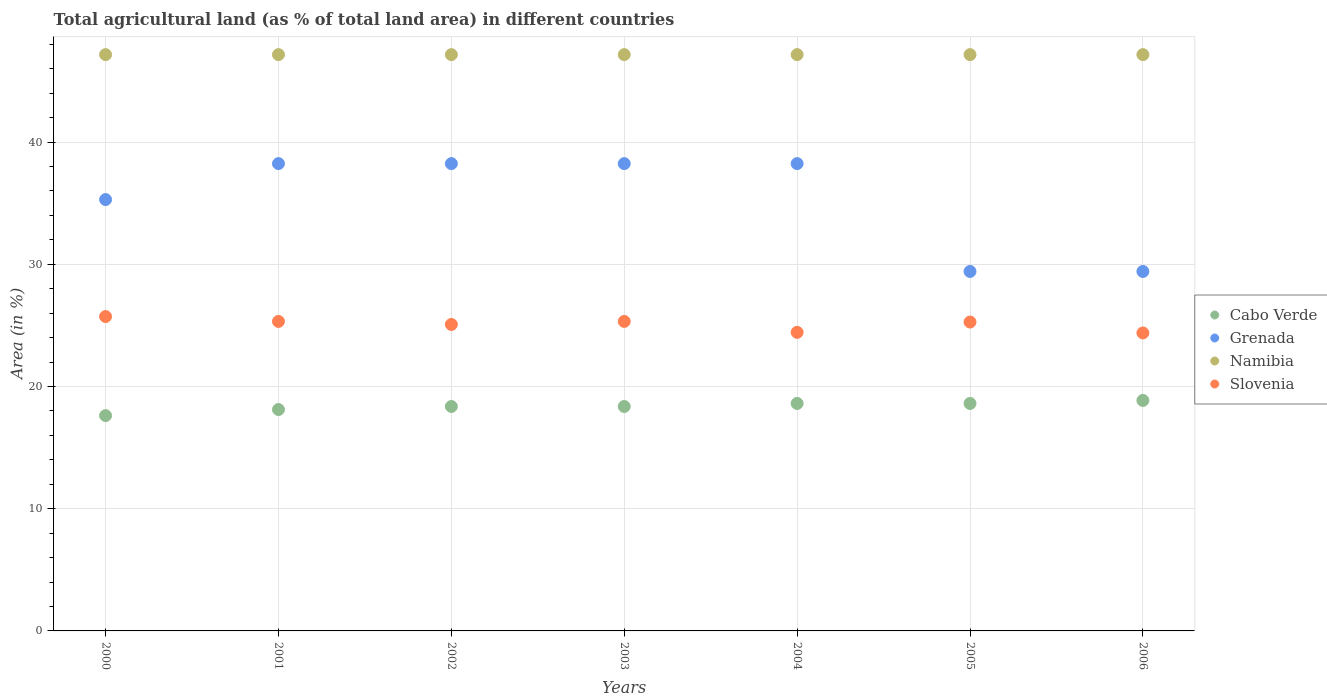How many different coloured dotlines are there?
Offer a terse response. 4. Is the number of dotlines equal to the number of legend labels?
Ensure brevity in your answer.  Yes. What is the percentage of agricultural land in Namibia in 2004?
Your answer should be very brief. 47.15. Across all years, what is the maximum percentage of agricultural land in Cabo Verde?
Give a very brief answer. 18.86. Across all years, what is the minimum percentage of agricultural land in Namibia?
Ensure brevity in your answer.  47.15. In which year was the percentage of agricultural land in Grenada minimum?
Make the answer very short. 2005. What is the total percentage of agricultural land in Cabo Verde in the graph?
Provide a succinct answer. 128.54. What is the difference between the percentage of agricultural land in Slovenia in 2000 and that in 2002?
Keep it short and to the point. 0.65. What is the difference between the percentage of agricultural land in Slovenia in 2006 and the percentage of agricultural land in Grenada in 2000?
Your response must be concise. -10.91. What is the average percentage of agricultural land in Cabo Verde per year?
Keep it short and to the point. 18.36. In the year 2003, what is the difference between the percentage of agricultural land in Namibia and percentage of agricultural land in Grenada?
Your answer should be very brief. 8.92. In how many years, is the percentage of agricultural land in Cabo Verde greater than 12 %?
Offer a very short reply. 7. What is the ratio of the percentage of agricultural land in Grenada in 2004 to that in 2006?
Offer a very short reply. 1.3. Is the percentage of agricultural land in Cabo Verde in 2000 less than that in 2001?
Keep it short and to the point. Yes. Is the difference between the percentage of agricultural land in Namibia in 2002 and 2004 greater than the difference between the percentage of agricultural land in Grenada in 2002 and 2004?
Make the answer very short. No. What is the difference between the highest and the second highest percentage of agricultural land in Grenada?
Make the answer very short. 0. What is the difference between the highest and the lowest percentage of agricultural land in Grenada?
Keep it short and to the point. 8.82. In how many years, is the percentage of agricultural land in Cabo Verde greater than the average percentage of agricultural land in Cabo Verde taken over all years?
Provide a succinct answer. 3. Is the sum of the percentage of agricultural land in Slovenia in 2001 and 2006 greater than the maximum percentage of agricultural land in Namibia across all years?
Provide a short and direct response. Yes. Is it the case that in every year, the sum of the percentage of agricultural land in Cabo Verde and percentage of agricultural land in Grenada  is greater than the sum of percentage of agricultural land in Slovenia and percentage of agricultural land in Namibia?
Keep it short and to the point. No. Is it the case that in every year, the sum of the percentage of agricultural land in Grenada and percentage of agricultural land in Cabo Verde  is greater than the percentage of agricultural land in Namibia?
Offer a terse response. Yes. Does the percentage of agricultural land in Slovenia monotonically increase over the years?
Offer a terse response. No. Is the percentage of agricultural land in Grenada strictly greater than the percentage of agricultural land in Cabo Verde over the years?
Make the answer very short. Yes. Is the percentage of agricultural land in Namibia strictly less than the percentage of agricultural land in Grenada over the years?
Your answer should be compact. No. How many dotlines are there?
Keep it short and to the point. 4. Does the graph contain any zero values?
Your answer should be compact. No. Where does the legend appear in the graph?
Offer a very short reply. Center right. How are the legend labels stacked?
Offer a terse response. Vertical. What is the title of the graph?
Offer a terse response. Total agricultural land (as % of total land area) in different countries. What is the label or title of the Y-axis?
Provide a short and direct response. Area (in %). What is the Area (in %) in Cabo Verde in 2000?
Your answer should be very brief. 17.62. What is the Area (in %) of Grenada in 2000?
Provide a short and direct response. 35.29. What is the Area (in %) in Namibia in 2000?
Provide a succinct answer. 47.15. What is the Area (in %) in Slovenia in 2000?
Offer a very short reply. 25.72. What is the Area (in %) in Cabo Verde in 2001?
Ensure brevity in your answer.  18.11. What is the Area (in %) of Grenada in 2001?
Keep it short and to the point. 38.24. What is the Area (in %) of Namibia in 2001?
Provide a succinct answer. 47.15. What is the Area (in %) of Slovenia in 2001?
Give a very brief answer. 25.32. What is the Area (in %) of Cabo Verde in 2002?
Your response must be concise. 18.36. What is the Area (in %) in Grenada in 2002?
Your response must be concise. 38.24. What is the Area (in %) in Namibia in 2002?
Provide a succinct answer. 47.15. What is the Area (in %) of Slovenia in 2002?
Ensure brevity in your answer.  25.07. What is the Area (in %) in Cabo Verde in 2003?
Your response must be concise. 18.36. What is the Area (in %) of Grenada in 2003?
Ensure brevity in your answer.  38.24. What is the Area (in %) of Namibia in 2003?
Provide a succinct answer. 47.15. What is the Area (in %) of Slovenia in 2003?
Give a very brief answer. 25.32. What is the Area (in %) in Cabo Verde in 2004?
Give a very brief answer. 18.61. What is the Area (in %) of Grenada in 2004?
Offer a terse response. 38.24. What is the Area (in %) in Namibia in 2004?
Provide a succinct answer. 47.15. What is the Area (in %) in Slovenia in 2004?
Your answer should be compact. 24.43. What is the Area (in %) in Cabo Verde in 2005?
Make the answer very short. 18.61. What is the Area (in %) of Grenada in 2005?
Ensure brevity in your answer.  29.41. What is the Area (in %) in Namibia in 2005?
Provide a short and direct response. 47.15. What is the Area (in %) in Slovenia in 2005?
Your response must be concise. 25.27. What is the Area (in %) in Cabo Verde in 2006?
Your answer should be compact. 18.86. What is the Area (in %) in Grenada in 2006?
Provide a succinct answer. 29.41. What is the Area (in %) in Namibia in 2006?
Provide a succinct answer. 47.15. What is the Area (in %) in Slovenia in 2006?
Keep it short and to the point. 24.38. Across all years, what is the maximum Area (in %) of Cabo Verde?
Give a very brief answer. 18.86. Across all years, what is the maximum Area (in %) of Grenada?
Make the answer very short. 38.24. Across all years, what is the maximum Area (in %) in Namibia?
Offer a terse response. 47.15. Across all years, what is the maximum Area (in %) in Slovenia?
Provide a short and direct response. 25.72. Across all years, what is the minimum Area (in %) of Cabo Verde?
Offer a very short reply. 17.62. Across all years, what is the minimum Area (in %) of Grenada?
Provide a short and direct response. 29.41. Across all years, what is the minimum Area (in %) of Namibia?
Offer a terse response. 47.15. Across all years, what is the minimum Area (in %) in Slovenia?
Make the answer very short. 24.38. What is the total Area (in %) of Cabo Verde in the graph?
Your answer should be very brief. 128.54. What is the total Area (in %) of Grenada in the graph?
Give a very brief answer. 247.06. What is the total Area (in %) of Namibia in the graph?
Provide a succinct answer. 330.07. What is the total Area (in %) of Slovenia in the graph?
Offer a terse response. 175.52. What is the difference between the Area (in %) of Cabo Verde in 2000 and that in 2001?
Your response must be concise. -0.5. What is the difference between the Area (in %) in Grenada in 2000 and that in 2001?
Your answer should be compact. -2.94. What is the difference between the Area (in %) in Namibia in 2000 and that in 2001?
Your answer should be very brief. 0. What is the difference between the Area (in %) of Slovenia in 2000 and that in 2001?
Your answer should be compact. 0.4. What is the difference between the Area (in %) in Cabo Verde in 2000 and that in 2002?
Your answer should be compact. -0.74. What is the difference between the Area (in %) in Grenada in 2000 and that in 2002?
Offer a very short reply. -2.94. What is the difference between the Area (in %) of Namibia in 2000 and that in 2002?
Provide a succinct answer. 0. What is the difference between the Area (in %) in Slovenia in 2000 and that in 2002?
Your response must be concise. 0.65. What is the difference between the Area (in %) of Cabo Verde in 2000 and that in 2003?
Make the answer very short. -0.74. What is the difference between the Area (in %) in Grenada in 2000 and that in 2003?
Give a very brief answer. -2.94. What is the difference between the Area (in %) of Slovenia in 2000 and that in 2003?
Keep it short and to the point. 0.4. What is the difference between the Area (in %) of Cabo Verde in 2000 and that in 2004?
Your response must be concise. -0.99. What is the difference between the Area (in %) in Grenada in 2000 and that in 2004?
Your answer should be compact. -2.94. What is the difference between the Area (in %) in Slovenia in 2000 and that in 2004?
Make the answer very short. 1.29. What is the difference between the Area (in %) of Cabo Verde in 2000 and that in 2005?
Offer a terse response. -0.99. What is the difference between the Area (in %) in Grenada in 2000 and that in 2005?
Your response must be concise. 5.88. What is the difference between the Area (in %) of Slovenia in 2000 and that in 2005?
Keep it short and to the point. 0.45. What is the difference between the Area (in %) in Cabo Verde in 2000 and that in 2006?
Your answer should be very brief. -1.24. What is the difference between the Area (in %) in Grenada in 2000 and that in 2006?
Make the answer very short. 5.88. What is the difference between the Area (in %) in Namibia in 2000 and that in 2006?
Ensure brevity in your answer.  0. What is the difference between the Area (in %) of Slovenia in 2000 and that in 2006?
Give a very brief answer. 1.34. What is the difference between the Area (in %) in Cabo Verde in 2001 and that in 2002?
Provide a succinct answer. -0.25. What is the difference between the Area (in %) of Grenada in 2001 and that in 2002?
Ensure brevity in your answer.  0. What is the difference between the Area (in %) in Namibia in 2001 and that in 2002?
Provide a succinct answer. 0. What is the difference between the Area (in %) of Slovenia in 2001 and that in 2002?
Make the answer very short. 0.25. What is the difference between the Area (in %) of Cabo Verde in 2001 and that in 2003?
Give a very brief answer. -0.25. What is the difference between the Area (in %) in Grenada in 2001 and that in 2003?
Provide a succinct answer. 0. What is the difference between the Area (in %) of Slovenia in 2001 and that in 2003?
Your answer should be very brief. 0. What is the difference between the Area (in %) of Cabo Verde in 2001 and that in 2004?
Provide a short and direct response. -0.5. What is the difference between the Area (in %) of Namibia in 2001 and that in 2004?
Give a very brief answer. 0. What is the difference between the Area (in %) of Slovenia in 2001 and that in 2004?
Offer a very short reply. 0.89. What is the difference between the Area (in %) of Cabo Verde in 2001 and that in 2005?
Provide a succinct answer. -0.5. What is the difference between the Area (in %) in Grenada in 2001 and that in 2005?
Keep it short and to the point. 8.82. What is the difference between the Area (in %) in Namibia in 2001 and that in 2005?
Your answer should be compact. 0. What is the difference between the Area (in %) in Slovenia in 2001 and that in 2005?
Offer a very short reply. 0.05. What is the difference between the Area (in %) in Cabo Verde in 2001 and that in 2006?
Your response must be concise. -0.74. What is the difference between the Area (in %) in Grenada in 2001 and that in 2006?
Give a very brief answer. 8.82. What is the difference between the Area (in %) of Slovenia in 2001 and that in 2006?
Make the answer very short. 0.94. What is the difference between the Area (in %) of Namibia in 2002 and that in 2003?
Your answer should be compact. 0. What is the difference between the Area (in %) of Slovenia in 2002 and that in 2003?
Provide a succinct answer. -0.25. What is the difference between the Area (in %) in Cabo Verde in 2002 and that in 2004?
Give a very brief answer. -0.25. What is the difference between the Area (in %) in Grenada in 2002 and that in 2004?
Offer a terse response. 0. What is the difference between the Area (in %) in Slovenia in 2002 and that in 2004?
Your response must be concise. 0.65. What is the difference between the Area (in %) of Cabo Verde in 2002 and that in 2005?
Your answer should be compact. -0.25. What is the difference between the Area (in %) of Grenada in 2002 and that in 2005?
Give a very brief answer. 8.82. What is the difference between the Area (in %) of Slovenia in 2002 and that in 2005?
Give a very brief answer. -0.2. What is the difference between the Area (in %) of Cabo Verde in 2002 and that in 2006?
Offer a very short reply. -0.5. What is the difference between the Area (in %) in Grenada in 2002 and that in 2006?
Your answer should be very brief. 8.82. What is the difference between the Area (in %) in Slovenia in 2002 and that in 2006?
Provide a short and direct response. 0.7. What is the difference between the Area (in %) of Cabo Verde in 2003 and that in 2004?
Ensure brevity in your answer.  -0.25. What is the difference between the Area (in %) in Grenada in 2003 and that in 2004?
Offer a terse response. 0. What is the difference between the Area (in %) in Namibia in 2003 and that in 2004?
Make the answer very short. 0. What is the difference between the Area (in %) of Slovenia in 2003 and that in 2004?
Keep it short and to the point. 0.89. What is the difference between the Area (in %) of Cabo Verde in 2003 and that in 2005?
Provide a succinct answer. -0.25. What is the difference between the Area (in %) in Grenada in 2003 and that in 2005?
Offer a very short reply. 8.82. What is the difference between the Area (in %) of Namibia in 2003 and that in 2005?
Make the answer very short. 0. What is the difference between the Area (in %) of Slovenia in 2003 and that in 2005?
Give a very brief answer. 0.05. What is the difference between the Area (in %) in Cabo Verde in 2003 and that in 2006?
Keep it short and to the point. -0.5. What is the difference between the Area (in %) in Grenada in 2003 and that in 2006?
Provide a short and direct response. 8.82. What is the difference between the Area (in %) of Namibia in 2003 and that in 2006?
Your answer should be compact. 0. What is the difference between the Area (in %) of Slovenia in 2003 and that in 2006?
Give a very brief answer. 0.94. What is the difference between the Area (in %) in Grenada in 2004 and that in 2005?
Give a very brief answer. 8.82. What is the difference between the Area (in %) in Slovenia in 2004 and that in 2005?
Your answer should be very brief. -0.84. What is the difference between the Area (in %) of Cabo Verde in 2004 and that in 2006?
Ensure brevity in your answer.  -0.25. What is the difference between the Area (in %) in Grenada in 2004 and that in 2006?
Offer a terse response. 8.82. What is the difference between the Area (in %) of Slovenia in 2004 and that in 2006?
Provide a succinct answer. 0.05. What is the difference between the Area (in %) of Cabo Verde in 2005 and that in 2006?
Ensure brevity in your answer.  -0.25. What is the difference between the Area (in %) of Grenada in 2005 and that in 2006?
Your answer should be compact. 0. What is the difference between the Area (in %) in Slovenia in 2005 and that in 2006?
Ensure brevity in your answer.  0.89. What is the difference between the Area (in %) in Cabo Verde in 2000 and the Area (in %) in Grenada in 2001?
Give a very brief answer. -20.62. What is the difference between the Area (in %) of Cabo Verde in 2000 and the Area (in %) of Namibia in 2001?
Make the answer very short. -29.53. What is the difference between the Area (in %) of Cabo Verde in 2000 and the Area (in %) of Slovenia in 2001?
Provide a short and direct response. -7.7. What is the difference between the Area (in %) in Grenada in 2000 and the Area (in %) in Namibia in 2001?
Keep it short and to the point. -11.86. What is the difference between the Area (in %) of Grenada in 2000 and the Area (in %) of Slovenia in 2001?
Ensure brevity in your answer.  9.97. What is the difference between the Area (in %) in Namibia in 2000 and the Area (in %) in Slovenia in 2001?
Your answer should be compact. 21.83. What is the difference between the Area (in %) in Cabo Verde in 2000 and the Area (in %) in Grenada in 2002?
Ensure brevity in your answer.  -20.62. What is the difference between the Area (in %) in Cabo Verde in 2000 and the Area (in %) in Namibia in 2002?
Keep it short and to the point. -29.53. What is the difference between the Area (in %) of Cabo Verde in 2000 and the Area (in %) of Slovenia in 2002?
Offer a very short reply. -7.46. What is the difference between the Area (in %) of Grenada in 2000 and the Area (in %) of Namibia in 2002?
Make the answer very short. -11.86. What is the difference between the Area (in %) in Grenada in 2000 and the Area (in %) in Slovenia in 2002?
Ensure brevity in your answer.  10.22. What is the difference between the Area (in %) in Namibia in 2000 and the Area (in %) in Slovenia in 2002?
Provide a short and direct response. 22.08. What is the difference between the Area (in %) in Cabo Verde in 2000 and the Area (in %) in Grenada in 2003?
Ensure brevity in your answer.  -20.62. What is the difference between the Area (in %) of Cabo Verde in 2000 and the Area (in %) of Namibia in 2003?
Your answer should be very brief. -29.53. What is the difference between the Area (in %) in Cabo Verde in 2000 and the Area (in %) in Slovenia in 2003?
Your response must be concise. -7.7. What is the difference between the Area (in %) of Grenada in 2000 and the Area (in %) of Namibia in 2003?
Provide a short and direct response. -11.86. What is the difference between the Area (in %) in Grenada in 2000 and the Area (in %) in Slovenia in 2003?
Ensure brevity in your answer.  9.97. What is the difference between the Area (in %) of Namibia in 2000 and the Area (in %) of Slovenia in 2003?
Your answer should be compact. 21.83. What is the difference between the Area (in %) of Cabo Verde in 2000 and the Area (in %) of Grenada in 2004?
Make the answer very short. -20.62. What is the difference between the Area (in %) in Cabo Verde in 2000 and the Area (in %) in Namibia in 2004?
Offer a very short reply. -29.53. What is the difference between the Area (in %) of Cabo Verde in 2000 and the Area (in %) of Slovenia in 2004?
Give a very brief answer. -6.81. What is the difference between the Area (in %) in Grenada in 2000 and the Area (in %) in Namibia in 2004?
Your response must be concise. -11.86. What is the difference between the Area (in %) in Grenada in 2000 and the Area (in %) in Slovenia in 2004?
Keep it short and to the point. 10.87. What is the difference between the Area (in %) of Namibia in 2000 and the Area (in %) of Slovenia in 2004?
Your response must be concise. 22.72. What is the difference between the Area (in %) in Cabo Verde in 2000 and the Area (in %) in Grenada in 2005?
Your answer should be very brief. -11.79. What is the difference between the Area (in %) of Cabo Verde in 2000 and the Area (in %) of Namibia in 2005?
Provide a short and direct response. -29.53. What is the difference between the Area (in %) in Cabo Verde in 2000 and the Area (in %) in Slovenia in 2005?
Offer a very short reply. -7.66. What is the difference between the Area (in %) in Grenada in 2000 and the Area (in %) in Namibia in 2005?
Your response must be concise. -11.86. What is the difference between the Area (in %) of Grenada in 2000 and the Area (in %) of Slovenia in 2005?
Your response must be concise. 10.02. What is the difference between the Area (in %) of Namibia in 2000 and the Area (in %) of Slovenia in 2005?
Ensure brevity in your answer.  21.88. What is the difference between the Area (in %) in Cabo Verde in 2000 and the Area (in %) in Grenada in 2006?
Your answer should be very brief. -11.79. What is the difference between the Area (in %) of Cabo Verde in 2000 and the Area (in %) of Namibia in 2006?
Offer a terse response. -29.53. What is the difference between the Area (in %) of Cabo Verde in 2000 and the Area (in %) of Slovenia in 2006?
Provide a short and direct response. -6.76. What is the difference between the Area (in %) of Grenada in 2000 and the Area (in %) of Namibia in 2006?
Your response must be concise. -11.86. What is the difference between the Area (in %) of Grenada in 2000 and the Area (in %) of Slovenia in 2006?
Offer a terse response. 10.91. What is the difference between the Area (in %) of Namibia in 2000 and the Area (in %) of Slovenia in 2006?
Provide a succinct answer. 22.77. What is the difference between the Area (in %) in Cabo Verde in 2001 and the Area (in %) in Grenada in 2002?
Your response must be concise. -20.12. What is the difference between the Area (in %) of Cabo Verde in 2001 and the Area (in %) of Namibia in 2002?
Make the answer very short. -29.04. What is the difference between the Area (in %) of Cabo Verde in 2001 and the Area (in %) of Slovenia in 2002?
Offer a very short reply. -6.96. What is the difference between the Area (in %) of Grenada in 2001 and the Area (in %) of Namibia in 2002?
Offer a very short reply. -8.92. What is the difference between the Area (in %) of Grenada in 2001 and the Area (in %) of Slovenia in 2002?
Provide a short and direct response. 13.16. What is the difference between the Area (in %) of Namibia in 2001 and the Area (in %) of Slovenia in 2002?
Offer a very short reply. 22.08. What is the difference between the Area (in %) of Cabo Verde in 2001 and the Area (in %) of Grenada in 2003?
Make the answer very short. -20.12. What is the difference between the Area (in %) of Cabo Verde in 2001 and the Area (in %) of Namibia in 2003?
Your answer should be compact. -29.04. What is the difference between the Area (in %) in Cabo Verde in 2001 and the Area (in %) in Slovenia in 2003?
Provide a succinct answer. -7.21. What is the difference between the Area (in %) in Grenada in 2001 and the Area (in %) in Namibia in 2003?
Provide a succinct answer. -8.92. What is the difference between the Area (in %) of Grenada in 2001 and the Area (in %) of Slovenia in 2003?
Make the answer very short. 12.91. What is the difference between the Area (in %) of Namibia in 2001 and the Area (in %) of Slovenia in 2003?
Your answer should be compact. 21.83. What is the difference between the Area (in %) in Cabo Verde in 2001 and the Area (in %) in Grenada in 2004?
Your answer should be very brief. -20.12. What is the difference between the Area (in %) of Cabo Verde in 2001 and the Area (in %) of Namibia in 2004?
Offer a very short reply. -29.04. What is the difference between the Area (in %) of Cabo Verde in 2001 and the Area (in %) of Slovenia in 2004?
Provide a succinct answer. -6.31. What is the difference between the Area (in %) in Grenada in 2001 and the Area (in %) in Namibia in 2004?
Keep it short and to the point. -8.92. What is the difference between the Area (in %) of Grenada in 2001 and the Area (in %) of Slovenia in 2004?
Provide a succinct answer. 13.81. What is the difference between the Area (in %) in Namibia in 2001 and the Area (in %) in Slovenia in 2004?
Your answer should be very brief. 22.72. What is the difference between the Area (in %) in Cabo Verde in 2001 and the Area (in %) in Grenada in 2005?
Ensure brevity in your answer.  -11.3. What is the difference between the Area (in %) in Cabo Verde in 2001 and the Area (in %) in Namibia in 2005?
Your answer should be compact. -29.04. What is the difference between the Area (in %) in Cabo Verde in 2001 and the Area (in %) in Slovenia in 2005?
Provide a succinct answer. -7.16. What is the difference between the Area (in %) of Grenada in 2001 and the Area (in %) of Namibia in 2005?
Your answer should be very brief. -8.92. What is the difference between the Area (in %) of Grenada in 2001 and the Area (in %) of Slovenia in 2005?
Provide a succinct answer. 12.96. What is the difference between the Area (in %) of Namibia in 2001 and the Area (in %) of Slovenia in 2005?
Provide a short and direct response. 21.88. What is the difference between the Area (in %) of Cabo Verde in 2001 and the Area (in %) of Grenada in 2006?
Offer a terse response. -11.3. What is the difference between the Area (in %) of Cabo Verde in 2001 and the Area (in %) of Namibia in 2006?
Your answer should be very brief. -29.04. What is the difference between the Area (in %) of Cabo Verde in 2001 and the Area (in %) of Slovenia in 2006?
Provide a succinct answer. -6.27. What is the difference between the Area (in %) in Grenada in 2001 and the Area (in %) in Namibia in 2006?
Your answer should be very brief. -8.92. What is the difference between the Area (in %) in Grenada in 2001 and the Area (in %) in Slovenia in 2006?
Make the answer very short. 13.86. What is the difference between the Area (in %) in Namibia in 2001 and the Area (in %) in Slovenia in 2006?
Give a very brief answer. 22.77. What is the difference between the Area (in %) of Cabo Verde in 2002 and the Area (in %) of Grenada in 2003?
Your answer should be very brief. -19.87. What is the difference between the Area (in %) in Cabo Verde in 2002 and the Area (in %) in Namibia in 2003?
Make the answer very short. -28.79. What is the difference between the Area (in %) in Cabo Verde in 2002 and the Area (in %) in Slovenia in 2003?
Offer a very short reply. -6.96. What is the difference between the Area (in %) in Grenada in 2002 and the Area (in %) in Namibia in 2003?
Keep it short and to the point. -8.92. What is the difference between the Area (in %) in Grenada in 2002 and the Area (in %) in Slovenia in 2003?
Your answer should be very brief. 12.91. What is the difference between the Area (in %) of Namibia in 2002 and the Area (in %) of Slovenia in 2003?
Your response must be concise. 21.83. What is the difference between the Area (in %) of Cabo Verde in 2002 and the Area (in %) of Grenada in 2004?
Make the answer very short. -19.87. What is the difference between the Area (in %) of Cabo Verde in 2002 and the Area (in %) of Namibia in 2004?
Your response must be concise. -28.79. What is the difference between the Area (in %) of Cabo Verde in 2002 and the Area (in %) of Slovenia in 2004?
Make the answer very short. -6.07. What is the difference between the Area (in %) in Grenada in 2002 and the Area (in %) in Namibia in 2004?
Give a very brief answer. -8.92. What is the difference between the Area (in %) of Grenada in 2002 and the Area (in %) of Slovenia in 2004?
Your response must be concise. 13.81. What is the difference between the Area (in %) in Namibia in 2002 and the Area (in %) in Slovenia in 2004?
Provide a succinct answer. 22.72. What is the difference between the Area (in %) of Cabo Verde in 2002 and the Area (in %) of Grenada in 2005?
Your response must be concise. -11.05. What is the difference between the Area (in %) in Cabo Verde in 2002 and the Area (in %) in Namibia in 2005?
Keep it short and to the point. -28.79. What is the difference between the Area (in %) of Cabo Verde in 2002 and the Area (in %) of Slovenia in 2005?
Provide a short and direct response. -6.91. What is the difference between the Area (in %) of Grenada in 2002 and the Area (in %) of Namibia in 2005?
Ensure brevity in your answer.  -8.92. What is the difference between the Area (in %) in Grenada in 2002 and the Area (in %) in Slovenia in 2005?
Give a very brief answer. 12.96. What is the difference between the Area (in %) in Namibia in 2002 and the Area (in %) in Slovenia in 2005?
Your answer should be compact. 21.88. What is the difference between the Area (in %) in Cabo Verde in 2002 and the Area (in %) in Grenada in 2006?
Offer a terse response. -11.05. What is the difference between the Area (in %) of Cabo Verde in 2002 and the Area (in %) of Namibia in 2006?
Give a very brief answer. -28.79. What is the difference between the Area (in %) in Cabo Verde in 2002 and the Area (in %) in Slovenia in 2006?
Offer a very short reply. -6.02. What is the difference between the Area (in %) in Grenada in 2002 and the Area (in %) in Namibia in 2006?
Make the answer very short. -8.92. What is the difference between the Area (in %) in Grenada in 2002 and the Area (in %) in Slovenia in 2006?
Give a very brief answer. 13.86. What is the difference between the Area (in %) of Namibia in 2002 and the Area (in %) of Slovenia in 2006?
Provide a succinct answer. 22.77. What is the difference between the Area (in %) of Cabo Verde in 2003 and the Area (in %) of Grenada in 2004?
Provide a succinct answer. -19.87. What is the difference between the Area (in %) in Cabo Verde in 2003 and the Area (in %) in Namibia in 2004?
Your answer should be very brief. -28.79. What is the difference between the Area (in %) of Cabo Verde in 2003 and the Area (in %) of Slovenia in 2004?
Offer a terse response. -6.07. What is the difference between the Area (in %) in Grenada in 2003 and the Area (in %) in Namibia in 2004?
Your answer should be very brief. -8.92. What is the difference between the Area (in %) in Grenada in 2003 and the Area (in %) in Slovenia in 2004?
Offer a very short reply. 13.81. What is the difference between the Area (in %) in Namibia in 2003 and the Area (in %) in Slovenia in 2004?
Your answer should be very brief. 22.72. What is the difference between the Area (in %) of Cabo Verde in 2003 and the Area (in %) of Grenada in 2005?
Offer a terse response. -11.05. What is the difference between the Area (in %) of Cabo Verde in 2003 and the Area (in %) of Namibia in 2005?
Provide a short and direct response. -28.79. What is the difference between the Area (in %) in Cabo Verde in 2003 and the Area (in %) in Slovenia in 2005?
Offer a terse response. -6.91. What is the difference between the Area (in %) of Grenada in 2003 and the Area (in %) of Namibia in 2005?
Keep it short and to the point. -8.92. What is the difference between the Area (in %) of Grenada in 2003 and the Area (in %) of Slovenia in 2005?
Your answer should be compact. 12.96. What is the difference between the Area (in %) in Namibia in 2003 and the Area (in %) in Slovenia in 2005?
Offer a terse response. 21.88. What is the difference between the Area (in %) in Cabo Verde in 2003 and the Area (in %) in Grenada in 2006?
Give a very brief answer. -11.05. What is the difference between the Area (in %) of Cabo Verde in 2003 and the Area (in %) of Namibia in 2006?
Provide a succinct answer. -28.79. What is the difference between the Area (in %) of Cabo Verde in 2003 and the Area (in %) of Slovenia in 2006?
Your answer should be compact. -6.02. What is the difference between the Area (in %) in Grenada in 2003 and the Area (in %) in Namibia in 2006?
Give a very brief answer. -8.92. What is the difference between the Area (in %) in Grenada in 2003 and the Area (in %) in Slovenia in 2006?
Ensure brevity in your answer.  13.86. What is the difference between the Area (in %) of Namibia in 2003 and the Area (in %) of Slovenia in 2006?
Your response must be concise. 22.77. What is the difference between the Area (in %) of Cabo Verde in 2004 and the Area (in %) of Grenada in 2005?
Your answer should be compact. -10.8. What is the difference between the Area (in %) of Cabo Verde in 2004 and the Area (in %) of Namibia in 2005?
Offer a very short reply. -28.54. What is the difference between the Area (in %) in Cabo Verde in 2004 and the Area (in %) in Slovenia in 2005?
Make the answer very short. -6.66. What is the difference between the Area (in %) in Grenada in 2004 and the Area (in %) in Namibia in 2005?
Offer a terse response. -8.92. What is the difference between the Area (in %) in Grenada in 2004 and the Area (in %) in Slovenia in 2005?
Offer a very short reply. 12.96. What is the difference between the Area (in %) in Namibia in 2004 and the Area (in %) in Slovenia in 2005?
Ensure brevity in your answer.  21.88. What is the difference between the Area (in %) in Cabo Verde in 2004 and the Area (in %) in Grenada in 2006?
Your answer should be compact. -10.8. What is the difference between the Area (in %) in Cabo Verde in 2004 and the Area (in %) in Namibia in 2006?
Ensure brevity in your answer.  -28.54. What is the difference between the Area (in %) in Cabo Verde in 2004 and the Area (in %) in Slovenia in 2006?
Your answer should be compact. -5.77. What is the difference between the Area (in %) in Grenada in 2004 and the Area (in %) in Namibia in 2006?
Give a very brief answer. -8.92. What is the difference between the Area (in %) in Grenada in 2004 and the Area (in %) in Slovenia in 2006?
Your answer should be compact. 13.86. What is the difference between the Area (in %) of Namibia in 2004 and the Area (in %) of Slovenia in 2006?
Your answer should be very brief. 22.77. What is the difference between the Area (in %) in Cabo Verde in 2005 and the Area (in %) in Grenada in 2006?
Make the answer very short. -10.8. What is the difference between the Area (in %) of Cabo Verde in 2005 and the Area (in %) of Namibia in 2006?
Offer a terse response. -28.54. What is the difference between the Area (in %) of Cabo Verde in 2005 and the Area (in %) of Slovenia in 2006?
Offer a very short reply. -5.77. What is the difference between the Area (in %) in Grenada in 2005 and the Area (in %) in Namibia in 2006?
Make the answer very short. -17.74. What is the difference between the Area (in %) in Grenada in 2005 and the Area (in %) in Slovenia in 2006?
Keep it short and to the point. 5.03. What is the difference between the Area (in %) in Namibia in 2005 and the Area (in %) in Slovenia in 2006?
Keep it short and to the point. 22.77. What is the average Area (in %) of Cabo Verde per year?
Provide a succinct answer. 18.36. What is the average Area (in %) in Grenada per year?
Give a very brief answer. 35.29. What is the average Area (in %) of Namibia per year?
Keep it short and to the point. 47.15. What is the average Area (in %) in Slovenia per year?
Offer a very short reply. 25.07. In the year 2000, what is the difference between the Area (in %) in Cabo Verde and Area (in %) in Grenada?
Offer a terse response. -17.68. In the year 2000, what is the difference between the Area (in %) of Cabo Verde and Area (in %) of Namibia?
Ensure brevity in your answer.  -29.53. In the year 2000, what is the difference between the Area (in %) of Cabo Verde and Area (in %) of Slovenia?
Offer a terse response. -8.1. In the year 2000, what is the difference between the Area (in %) in Grenada and Area (in %) in Namibia?
Give a very brief answer. -11.86. In the year 2000, what is the difference between the Area (in %) of Grenada and Area (in %) of Slovenia?
Keep it short and to the point. 9.57. In the year 2000, what is the difference between the Area (in %) of Namibia and Area (in %) of Slovenia?
Your answer should be very brief. 21.43. In the year 2001, what is the difference between the Area (in %) of Cabo Verde and Area (in %) of Grenada?
Your answer should be very brief. -20.12. In the year 2001, what is the difference between the Area (in %) of Cabo Verde and Area (in %) of Namibia?
Offer a terse response. -29.04. In the year 2001, what is the difference between the Area (in %) in Cabo Verde and Area (in %) in Slovenia?
Offer a terse response. -7.21. In the year 2001, what is the difference between the Area (in %) in Grenada and Area (in %) in Namibia?
Offer a terse response. -8.92. In the year 2001, what is the difference between the Area (in %) of Grenada and Area (in %) of Slovenia?
Provide a succinct answer. 12.91. In the year 2001, what is the difference between the Area (in %) in Namibia and Area (in %) in Slovenia?
Make the answer very short. 21.83. In the year 2002, what is the difference between the Area (in %) in Cabo Verde and Area (in %) in Grenada?
Keep it short and to the point. -19.87. In the year 2002, what is the difference between the Area (in %) in Cabo Verde and Area (in %) in Namibia?
Keep it short and to the point. -28.79. In the year 2002, what is the difference between the Area (in %) of Cabo Verde and Area (in %) of Slovenia?
Give a very brief answer. -6.71. In the year 2002, what is the difference between the Area (in %) in Grenada and Area (in %) in Namibia?
Make the answer very short. -8.92. In the year 2002, what is the difference between the Area (in %) in Grenada and Area (in %) in Slovenia?
Your response must be concise. 13.16. In the year 2002, what is the difference between the Area (in %) of Namibia and Area (in %) of Slovenia?
Your response must be concise. 22.08. In the year 2003, what is the difference between the Area (in %) of Cabo Verde and Area (in %) of Grenada?
Provide a succinct answer. -19.87. In the year 2003, what is the difference between the Area (in %) in Cabo Verde and Area (in %) in Namibia?
Provide a short and direct response. -28.79. In the year 2003, what is the difference between the Area (in %) in Cabo Verde and Area (in %) in Slovenia?
Provide a succinct answer. -6.96. In the year 2003, what is the difference between the Area (in %) of Grenada and Area (in %) of Namibia?
Your response must be concise. -8.92. In the year 2003, what is the difference between the Area (in %) of Grenada and Area (in %) of Slovenia?
Offer a terse response. 12.91. In the year 2003, what is the difference between the Area (in %) in Namibia and Area (in %) in Slovenia?
Your answer should be compact. 21.83. In the year 2004, what is the difference between the Area (in %) of Cabo Verde and Area (in %) of Grenada?
Your answer should be compact. -19.62. In the year 2004, what is the difference between the Area (in %) of Cabo Verde and Area (in %) of Namibia?
Make the answer very short. -28.54. In the year 2004, what is the difference between the Area (in %) in Cabo Verde and Area (in %) in Slovenia?
Give a very brief answer. -5.82. In the year 2004, what is the difference between the Area (in %) of Grenada and Area (in %) of Namibia?
Offer a very short reply. -8.92. In the year 2004, what is the difference between the Area (in %) of Grenada and Area (in %) of Slovenia?
Your answer should be very brief. 13.81. In the year 2004, what is the difference between the Area (in %) of Namibia and Area (in %) of Slovenia?
Offer a very short reply. 22.72. In the year 2005, what is the difference between the Area (in %) in Cabo Verde and Area (in %) in Grenada?
Ensure brevity in your answer.  -10.8. In the year 2005, what is the difference between the Area (in %) of Cabo Verde and Area (in %) of Namibia?
Provide a succinct answer. -28.54. In the year 2005, what is the difference between the Area (in %) in Cabo Verde and Area (in %) in Slovenia?
Ensure brevity in your answer.  -6.66. In the year 2005, what is the difference between the Area (in %) of Grenada and Area (in %) of Namibia?
Your answer should be compact. -17.74. In the year 2005, what is the difference between the Area (in %) of Grenada and Area (in %) of Slovenia?
Offer a terse response. 4.14. In the year 2005, what is the difference between the Area (in %) in Namibia and Area (in %) in Slovenia?
Ensure brevity in your answer.  21.88. In the year 2006, what is the difference between the Area (in %) in Cabo Verde and Area (in %) in Grenada?
Offer a very short reply. -10.55. In the year 2006, what is the difference between the Area (in %) in Cabo Verde and Area (in %) in Namibia?
Ensure brevity in your answer.  -28.29. In the year 2006, what is the difference between the Area (in %) in Cabo Verde and Area (in %) in Slovenia?
Offer a very short reply. -5.52. In the year 2006, what is the difference between the Area (in %) of Grenada and Area (in %) of Namibia?
Make the answer very short. -17.74. In the year 2006, what is the difference between the Area (in %) in Grenada and Area (in %) in Slovenia?
Provide a succinct answer. 5.03. In the year 2006, what is the difference between the Area (in %) of Namibia and Area (in %) of Slovenia?
Offer a terse response. 22.77. What is the ratio of the Area (in %) of Cabo Verde in 2000 to that in 2001?
Offer a terse response. 0.97. What is the ratio of the Area (in %) in Grenada in 2000 to that in 2001?
Your answer should be compact. 0.92. What is the ratio of the Area (in %) of Namibia in 2000 to that in 2001?
Your response must be concise. 1. What is the ratio of the Area (in %) in Slovenia in 2000 to that in 2001?
Give a very brief answer. 1.02. What is the ratio of the Area (in %) in Cabo Verde in 2000 to that in 2002?
Keep it short and to the point. 0.96. What is the ratio of the Area (in %) in Namibia in 2000 to that in 2002?
Offer a very short reply. 1. What is the ratio of the Area (in %) in Slovenia in 2000 to that in 2002?
Your answer should be very brief. 1.03. What is the ratio of the Area (in %) in Cabo Verde in 2000 to that in 2003?
Offer a very short reply. 0.96. What is the ratio of the Area (in %) in Grenada in 2000 to that in 2003?
Ensure brevity in your answer.  0.92. What is the ratio of the Area (in %) of Slovenia in 2000 to that in 2003?
Your answer should be very brief. 1.02. What is the ratio of the Area (in %) of Cabo Verde in 2000 to that in 2004?
Your answer should be very brief. 0.95. What is the ratio of the Area (in %) of Namibia in 2000 to that in 2004?
Keep it short and to the point. 1. What is the ratio of the Area (in %) in Slovenia in 2000 to that in 2004?
Provide a short and direct response. 1.05. What is the ratio of the Area (in %) of Cabo Verde in 2000 to that in 2005?
Make the answer very short. 0.95. What is the ratio of the Area (in %) in Slovenia in 2000 to that in 2005?
Your answer should be compact. 1.02. What is the ratio of the Area (in %) of Cabo Verde in 2000 to that in 2006?
Offer a very short reply. 0.93. What is the ratio of the Area (in %) of Slovenia in 2000 to that in 2006?
Ensure brevity in your answer.  1.05. What is the ratio of the Area (in %) of Cabo Verde in 2001 to that in 2002?
Ensure brevity in your answer.  0.99. What is the ratio of the Area (in %) of Namibia in 2001 to that in 2002?
Your answer should be very brief. 1. What is the ratio of the Area (in %) of Slovenia in 2001 to that in 2002?
Offer a terse response. 1.01. What is the ratio of the Area (in %) of Cabo Verde in 2001 to that in 2003?
Your answer should be compact. 0.99. What is the ratio of the Area (in %) of Namibia in 2001 to that in 2003?
Your response must be concise. 1. What is the ratio of the Area (in %) of Cabo Verde in 2001 to that in 2004?
Provide a short and direct response. 0.97. What is the ratio of the Area (in %) in Slovenia in 2001 to that in 2004?
Give a very brief answer. 1.04. What is the ratio of the Area (in %) in Cabo Verde in 2001 to that in 2005?
Offer a terse response. 0.97. What is the ratio of the Area (in %) of Namibia in 2001 to that in 2005?
Your response must be concise. 1. What is the ratio of the Area (in %) of Cabo Verde in 2001 to that in 2006?
Make the answer very short. 0.96. What is the ratio of the Area (in %) of Slovenia in 2001 to that in 2006?
Keep it short and to the point. 1.04. What is the ratio of the Area (in %) of Cabo Verde in 2002 to that in 2003?
Offer a very short reply. 1. What is the ratio of the Area (in %) of Grenada in 2002 to that in 2003?
Offer a terse response. 1. What is the ratio of the Area (in %) of Namibia in 2002 to that in 2003?
Ensure brevity in your answer.  1. What is the ratio of the Area (in %) in Slovenia in 2002 to that in 2003?
Provide a short and direct response. 0.99. What is the ratio of the Area (in %) of Cabo Verde in 2002 to that in 2004?
Keep it short and to the point. 0.99. What is the ratio of the Area (in %) in Namibia in 2002 to that in 2004?
Keep it short and to the point. 1. What is the ratio of the Area (in %) of Slovenia in 2002 to that in 2004?
Your response must be concise. 1.03. What is the ratio of the Area (in %) of Cabo Verde in 2002 to that in 2005?
Provide a succinct answer. 0.99. What is the ratio of the Area (in %) in Namibia in 2002 to that in 2005?
Your answer should be compact. 1. What is the ratio of the Area (in %) of Cabo Verde in 2002 to that in 2006?
Provide a short and direct response. 0.97. What is the ratio of the Area (in %) in Grenada in 2002 to that in 2006?
Your answer should be very brief. 1.3. What is the ratio of the Area (in %) in Namibia in 2002 to that in 2006?
Provide a short and direct response. 1. What is the ratio of the Area (in %) of Slovenia in 2002 to that in 2006?
Make the answer very short. 1.03. What is the ratio of the Area (in %) of Cabo Verde in 2003 to that in 2004?
Provide a succinct answer. 0.99. What is the ratio of the Area (in %) of Slovenia in 2003 to that in 2004?
Provide a short and direct response. 1.04. What is the ratio of the Area (in %) in Cabo Verde in 2003 to that in 2005?
Ensure brevity in your answer.  0.99. What is the ratio of the Area (in %) of Grenada in 2003 to that in 2005?
Give a very brief answer. 1.3. What is the ratio of the Area (in %) in Namibia in 2003 to that in 2005?
Ensure brevity in your answer.  1. What is the ratio of the Area (in %) of Slovenia in 2003 to that in 2005?
Your answer should be very brief. 1. What is the ratio of the Area (in %) of Cabo Verde in 2003 to that in 2006?
Provide a short and direct response. 0.97. What is the ratio of the Area (in %) of Slovenia in 2003 to that in 2006?
Give a very brief answer. 1.04. What is the ratio of the Area (in %) of Grenada in 2004 to that in 2005?
Ensure brevity in your answer.  1.3. What is the ratio of the Area (in %) in Namibia in 2004 to that in 2005?
Give a very brief answer. 1. What is the ratio of the Area (in %) of Slovenia in 2004 to that in 2005?
Offer a terse response. 0.97. What is the ratio of the Area (in %) of Slovenia in 2004 to that in 2006?
Make the answer very short. 1. What is the ratio of the Area (in %) in Slovenia in 2005 to that in 2006?
Your answer should be very brief. 1.04. What is the difference between the highest and the second highest Area (in %) of Cabo Verde?
Provide a succinct answer. 0.25. What is the difference between the highest and the second highest Area (in %) in Grenada?
Give a very brief answer. 0. What is the difference between the highest and the second highest Area (in %) of Namibia?
Give a very brief answer. 0. What is the difference between the highest and the second highest Area (in %) of Slovenia?
Offer a terse response. 0.4. What is the difference between the highest and the lowest Area (in %) of Cabo Verde?
Offer a very short reply. 1.24. What is the difference between the highest and the lowest Area (in %) in Grenada?
Provide a short and direct response. 8.82. What is the difference between the highest and the lowest Area (in %) of Namibia?
Provide a short and direct response. 0. What is the difference between the highest and the lowest Area (in %) in Slovenia?
Your response must be concise. 1.34. 